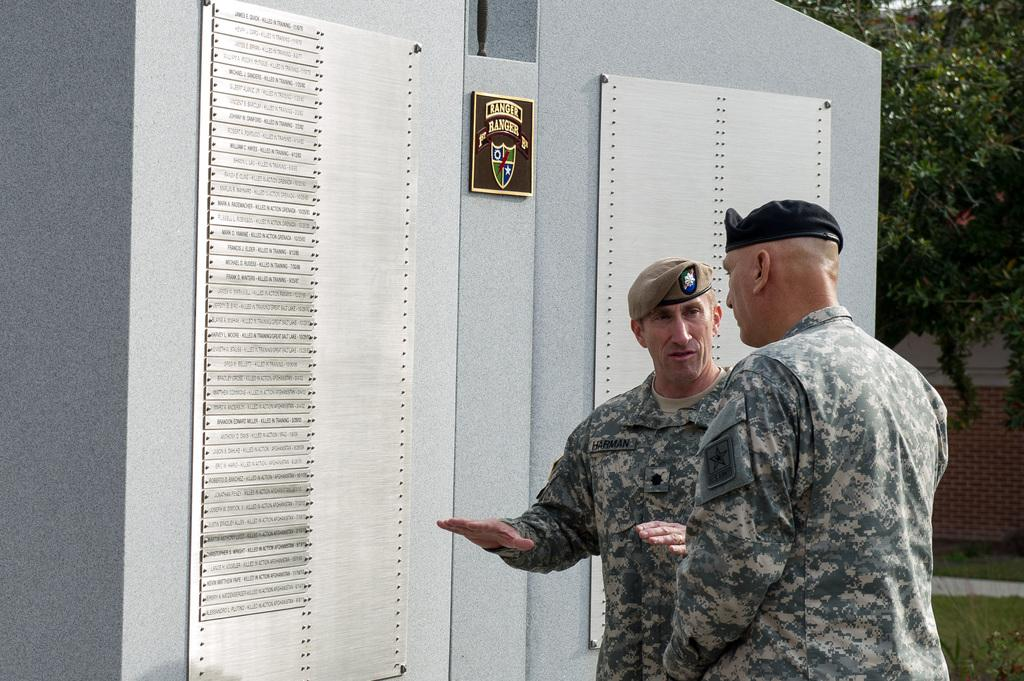What are the two people in the foreground of the image doing? The two people in the foreground of the image are talking. What can be seen in the middle of the image? There is a wall in the middle of the image. What is attached to the wall in the image? Two iron plates are attached to the wall. What type of vegetation is on the right side of the image? There are trees, plants, and grass on the right side of the image. What else can be seen on the right side of the image? There is a wall on the right side of the image. How many clocks are hanging on the wall on the right side of the image? There are no clocks visible in the image. What type of shoes are the people wearing in the image? The image does not show the people's shoes, so it cannot be determined from the image. 